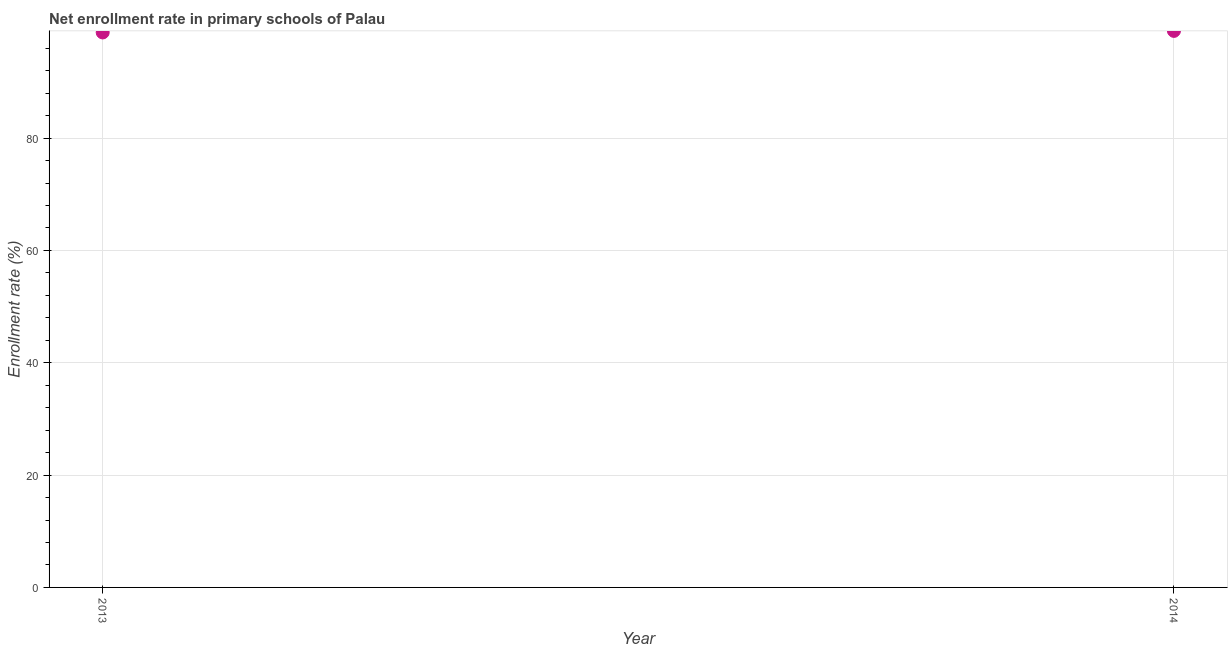What is the net enrollment rate in primary schools in 2014?
Make the answer very short. 99.09. Across all years, what is the maximum net enrollment rate in primary schools?
Provide a short and direct response. 99.09. Across all years, what is the minimum net enrollment rate in primary schools?
Give a very brief answer. 98.82. In which year was the net enrollment rate in primary schools minimum?
Make the answer very short. 2013. What is the sum of the net enrollment rate in primary schools?
Give a very brief answer. 197.91. What is the difference between the net enrollment rate in primary schools in 2013 and 2014?
Ensure brevity in your answer.  -0.28. What is the average net enrollment rate in primary schools per year?
Your response must be concise. 98.96. What is the median net enrollment rate in primary schools?
Make the answer very short. 98.96. In how many years, is the net enrollment rate in primary schools greater than 12 %?
Your answer should be compact. 2. Do a majority of the years between 2013 and 2014 (inclusive) have net enrollment rate in primary schools greater than 52 %?
Make the answer very short. Yes. What is the ratio of the net enrollment rate in primary schools in 2013 to that in 2014?
Keep it short and to the point. 1. Does the net enrollment rate in primary schools monotonically increase over the years?
Make the answer very short. Yes. Are the values on the major ticks of Y-axis written in scientific E-notation?
Provide a succinct answer. No. Does the graph contain grids?
Make the answer very short. Yes. What is the title of the graph?
Keep it short and to the point. Net enrollment rate in primary schools of Palau. What is the label or title of the Y-axis?
Your answer should be very brief. Enrollment rate (%). What is the Enrollment rate (%) in 2013?
Offer a terse response. 98.82. What is the Enrollment rate (%) in 2014?
Ensure brevity in your answer.  99.09. What is the difference between the Enrollment rate (%) in 2013 and 2014?
Ensure brevity in your answer.  -0.28. 